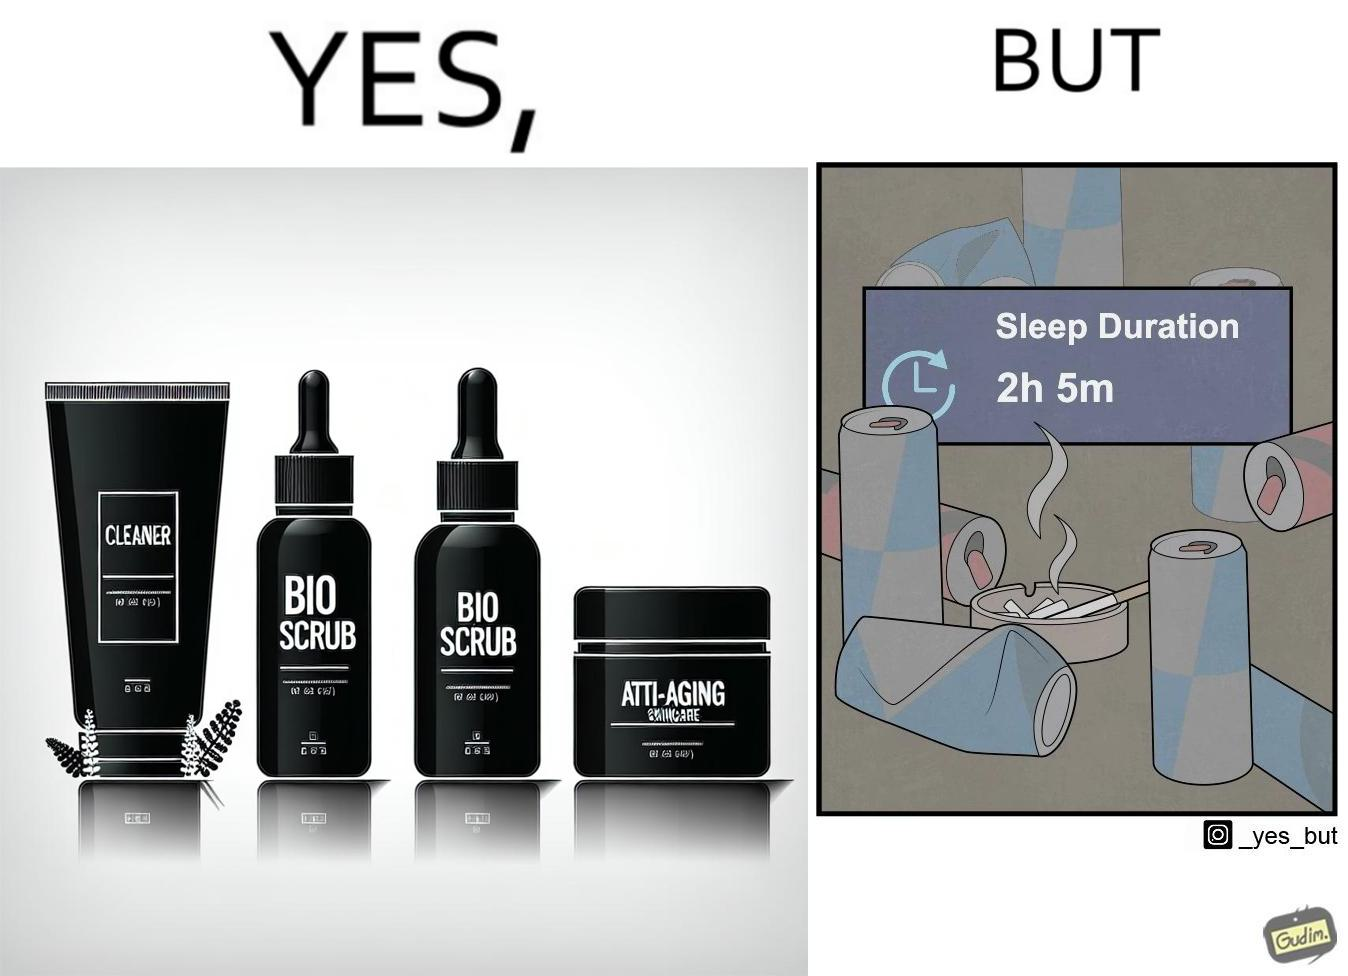Why is this image considered satirical? This image is ironic as on the one hand, the presumed person is into skincare and wants to do the best for their skin, which is good, but on the other hand, they are involved in unhealthy habits that will damage their skin like smoking, caffeine and inadequate sleep. 